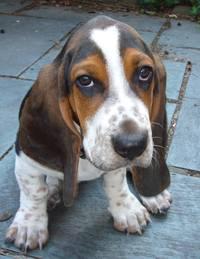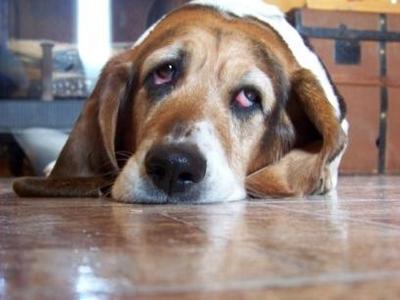The first image is the image on the left, the second image is the image on the right. Examine the images to the left and right. Is the description "One of the dog has its chin on a surface." accurate? Answer yes or no. Yes. 